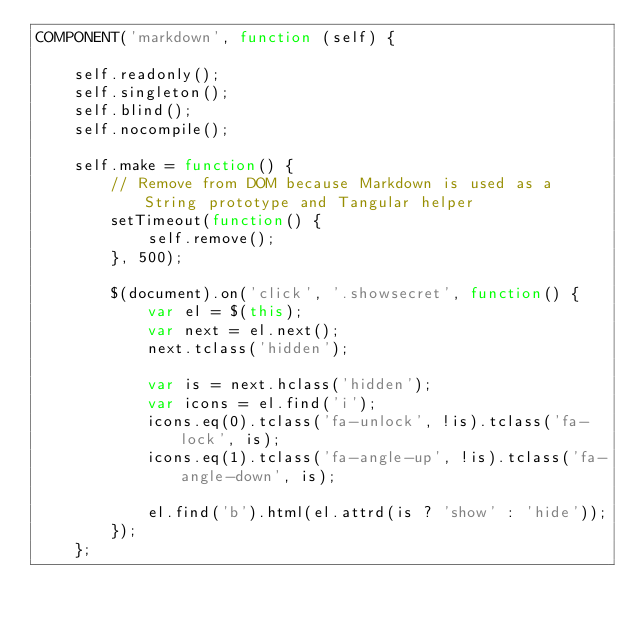<code> <loc_0><loc_0><loc_500><loc_500><_JavaScript_>COMPONENT('markdown', function (self) {

	self.readonly();
	self.singleton();
	self.blind();
	self.nocompile();

	self.make = function() {
		// Remove from DOM because Markdown is used as a String prototype and Tangular helper
		setTimeout(function() {
			self.remove();
		}, 500);

		$(document).on('click', '.showsecret', function() {
			var el = $(this);
			var next = el.next();
			next.tclass('hidden');

			var is = next.hclass('hidden');
			var icons = el.find('i');
			icons.eq(0).tclass('fa-unlock', !is).tclass('fa-lock', is);
			icons.eq(1).tclass('fa-angle-up', !is).tclass('fa-angle-down', is);

			el.find('b').html(el.attrd(is ? 'show' : 'hide'));
		});
	};
</code> 